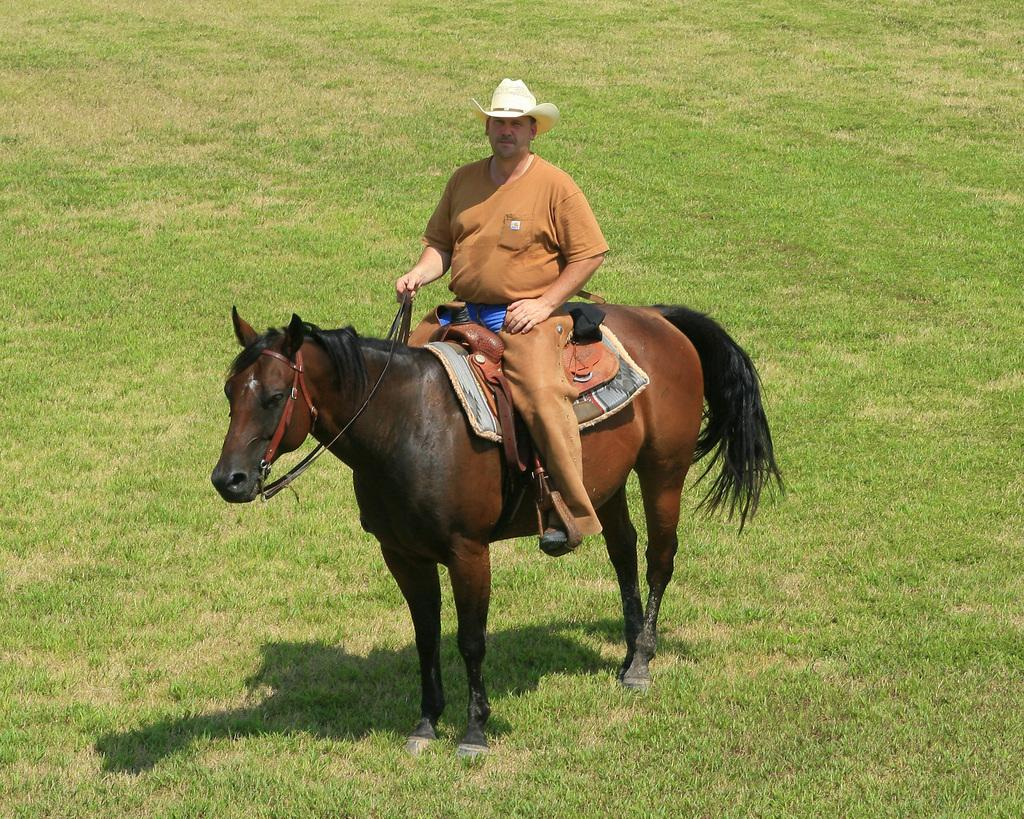What is the person doing in the image? The person is sitting on a horse. What is the color of the grass in the image? The grass is green in color. What type of headwear is the person wearing? The person is wearing a hat. Can you see the seashore in the image? No, there is no seashore visible in the image. What type of throat condition does the person on the horse have? There is no information about the person's throat condition in the image. 